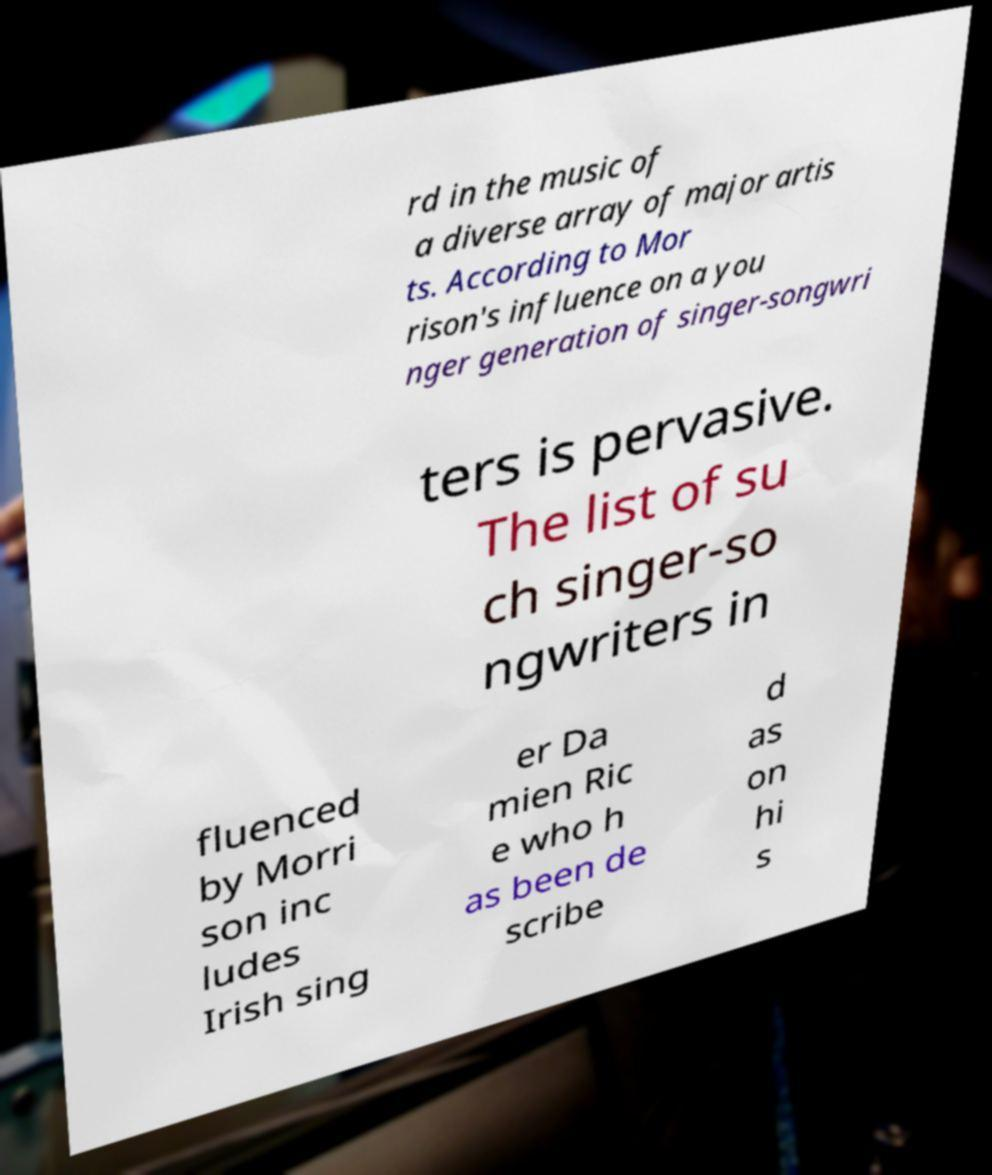I need the written content from this picture converted into text. Can you do that? rd in the music of a diverse array of major artis ts. According to Mor rison's influence on a you nger generation of singer-songwri ters is pervasive. The list of su ch singer-so ngwriters in fluenced by Morri son inc ludes Irish sing er Da mien Ric e who h as been de scribe d as on hi s 